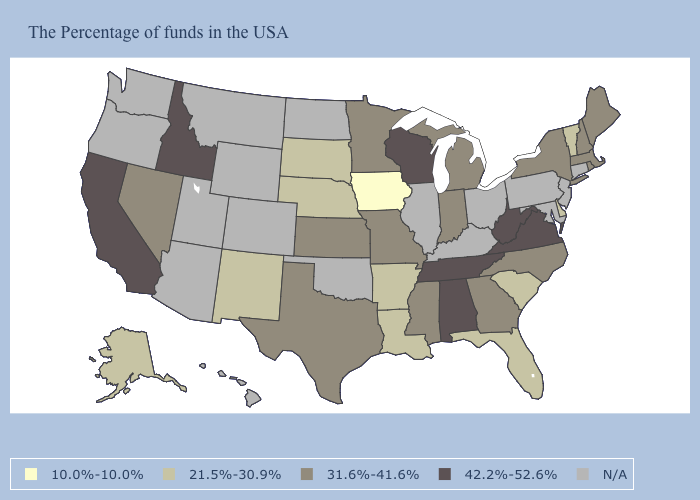Does the map have missing data?
Write a very short answer. Yes. Among the states that border Virginia , does North Carolina have the highest value?
Quick response, please. No. What is the value of Michigan?
Be succinct. 31.6%-41.6%. What is the lowest value in the USA?
Answer briefly. 10.0%-10.0%. What is the value of Alabama?
Write a very short answer. 42.2%-52.6%. Does the map have missing data?
Be succinct. Yes. Which states have the lowest value in the USA?
Be succinct. Iowa. What is the value of North Carolina?
Concise answer only. 31.6%-41.6%. What is the value of Minnesota?
Give a very brief answer. 31.6%-41.6%. Does New Mexico have the highest value in the West?
Answer briefly. No. What is the value of Minnesota?
Concise answer only. 31.6%-41.6%. Among the states that border Massachusetts , which have the lowest value?
Concise answer only. Vermont. What is the value of Ohio?
Be succinct. N/A. 